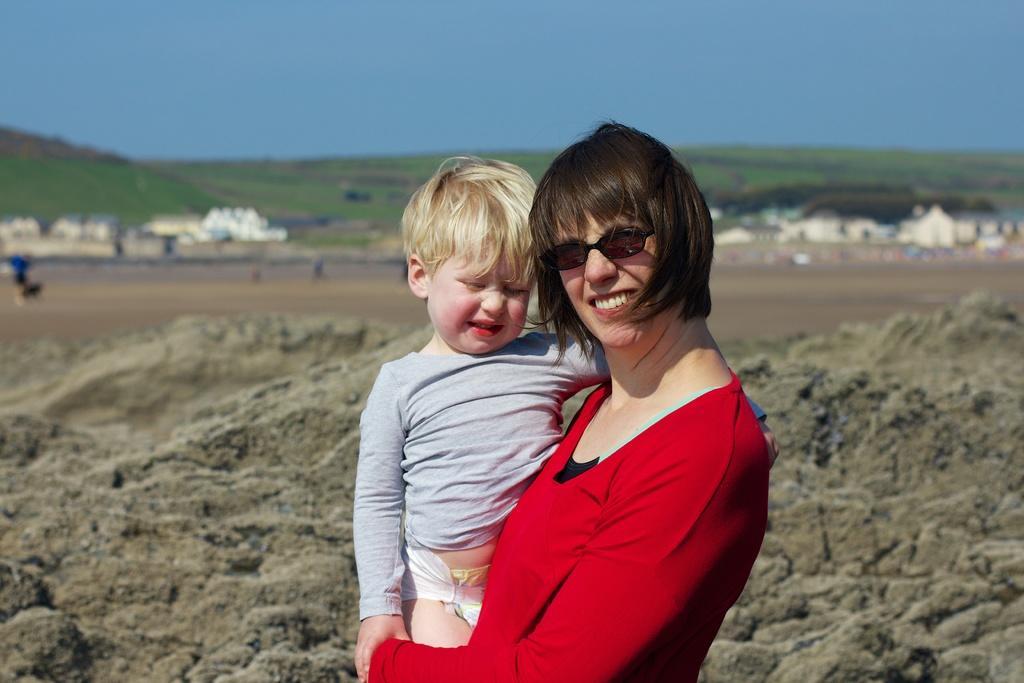Can you describe this image briefly? In the picture we can see a woman standing and holding a child, she is in a red T-shirt and smiling and behind them, we can see a rock surface and behind it, we can see sand surface and some houses, and hills with a grass surface and behind it we can see a sky. 